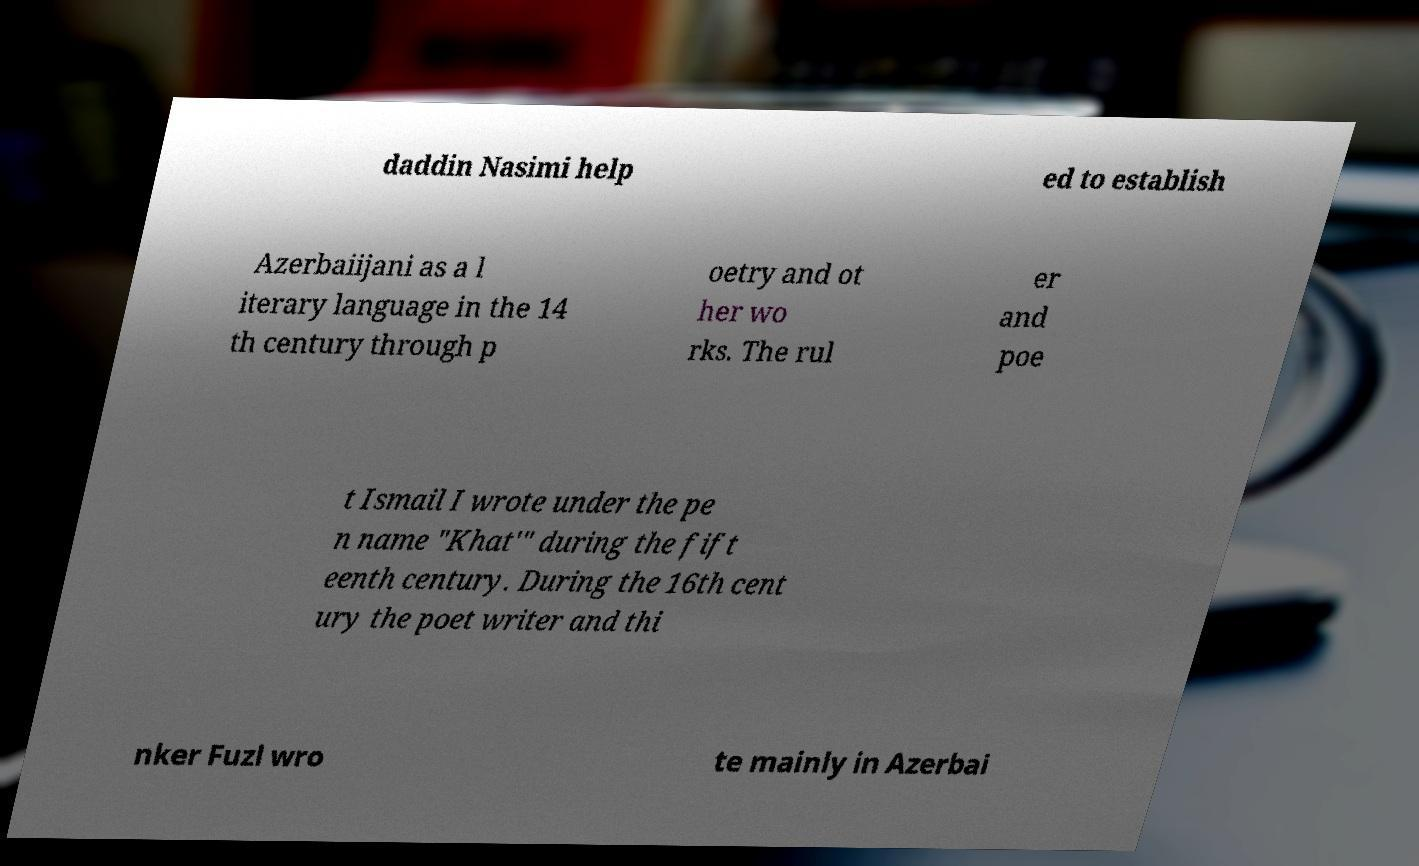There's text embedded in this image that I need extracted. Can you transcribe it verbatim? daddin Nasimi help ed to establish Azerbaiijani as a l iterary language in the 14 th century through p oetry and ot her wo rks. The rul er and poe t Ismail I wrote under the pe n name "Khat'" during the fift eenth century. During the 16th cent ury the poet writer and thi nker Fuzl wro te mainly in Azerbai 